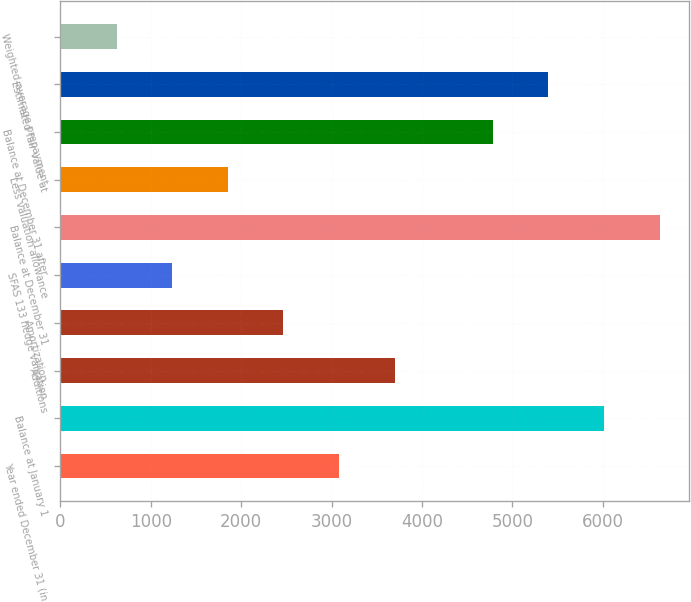<chart> <loc_0><loc_0><loc_500><loc_500><bar_chart><fcel>Year ended December 31 (in<fcel>Balance at January 1<fcel>Additions<fcel>Amortization<fcel>SFAS 133 hedge valuation<fcel>Balance at December 31<fcel>Less valuation allowance<fcel>Balance at December 31 after<fcel>Estimated fair value at<fcel>Weighted-average prepayment<nl><fcel>3083.16<fcel>6011.34<fcel>3698.33<fcel>2467.99<fcel>1237.65<fcel>6626.51<fcel>1852.82<fcel>4781<fcel>5396.17<fcel>622.48<nl></chart> 